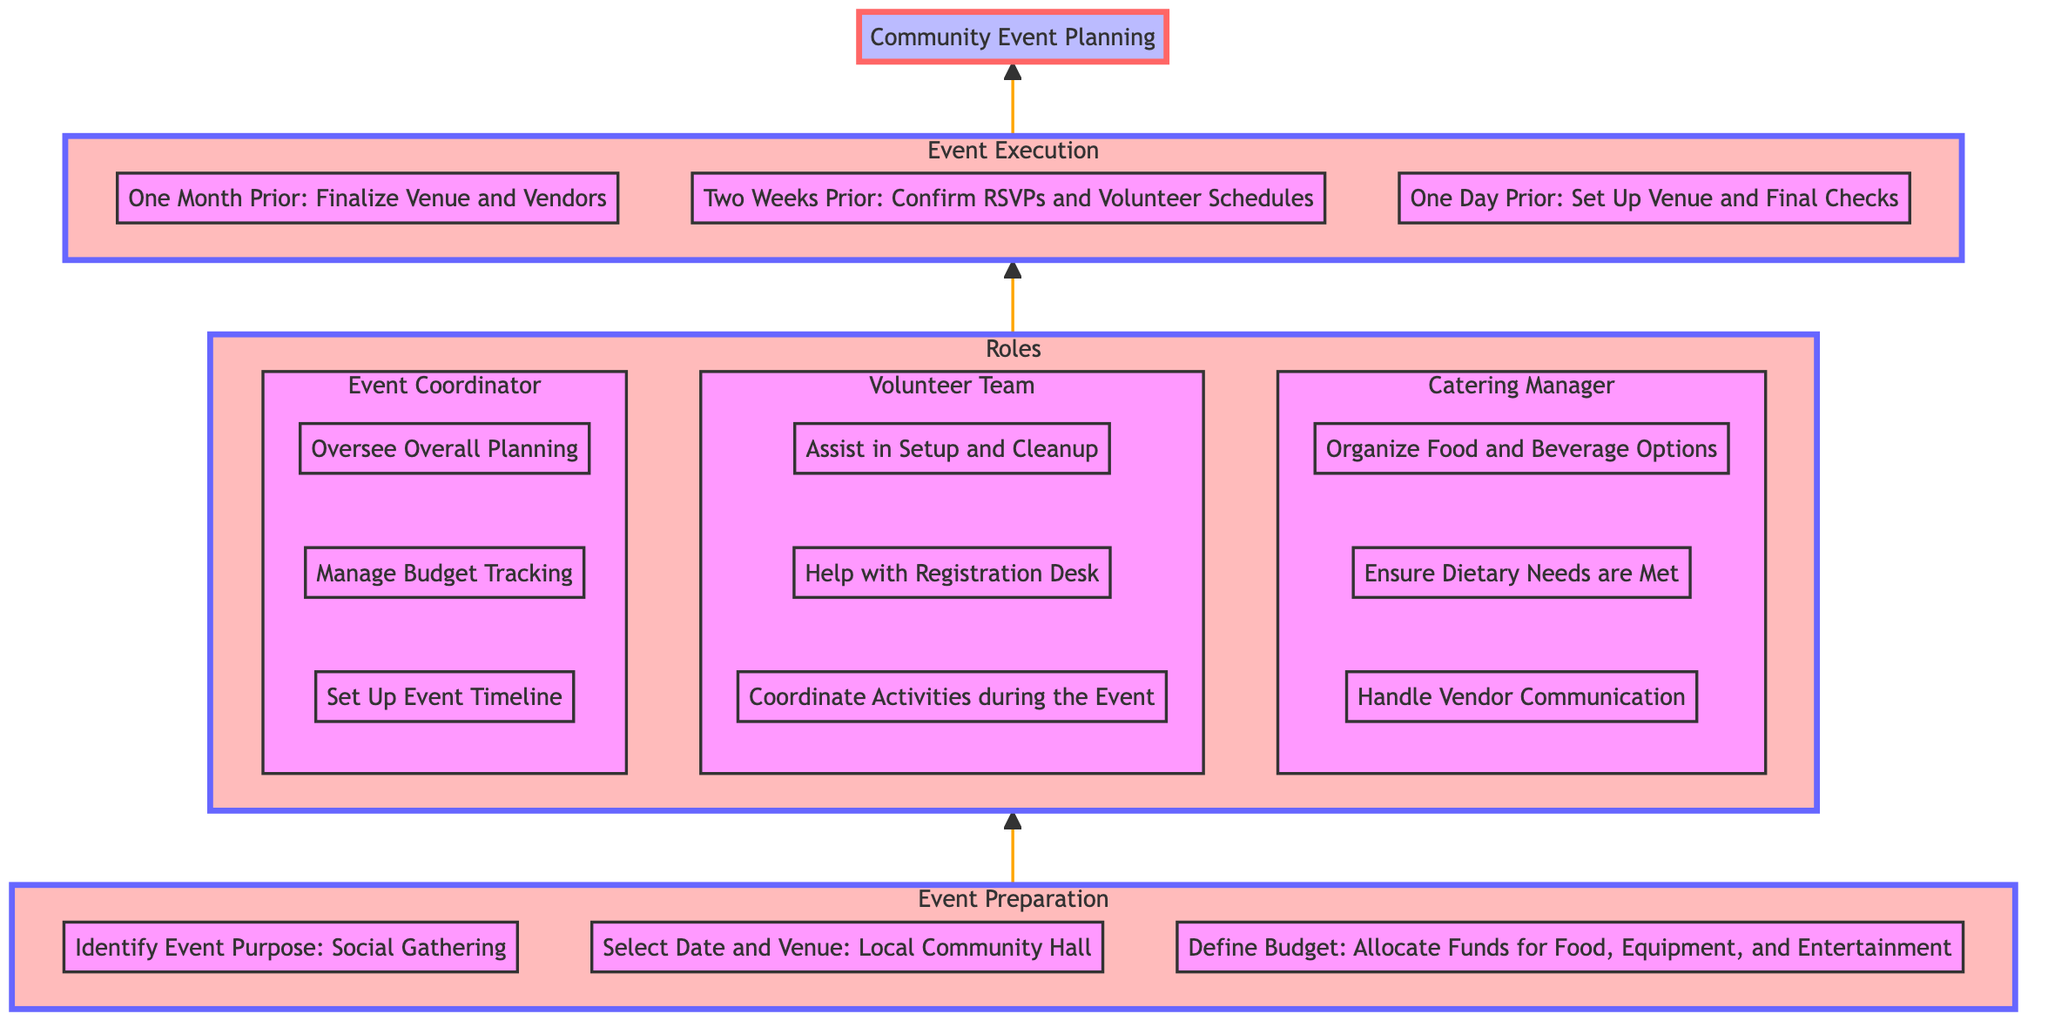What are the three tasks listed under Event Preparation? The diagram shows three specific tasks under Event Preparation: identifying the event purpose, selecting the date and venue, and defining the budget. These tasks are listed sequentially, and the focus is on the preparation stage before the actual event executes.
Answer: Identify Event Purpose: Social Gathering, Select Date and Venue: Local Community Hall, Define Budget: Allocate Funds for Food, Equipment, and Entertainment Who is responsible for managing the budget? The diagram indicates that the Event Coordinator is responsible for managing budget tracking, which is crucial for ensuring the event stays within financial limits and allocations made in the preparation stage are adhered to.
Answer: Event Coordinator What needs to be confirmed two weeks prior to the event? According to the diagram, the specific task that needs to be confirmed two weeks prior involves RSVPs and volunteer schedules. This is important for planning the flow and ensuring adequate staffing and attendance.
Answer: Confirm RSVPs and Volunteer Schedules How many roles are defined in the diagram? The diagram depicts three distinct roles: Event Coordinator, Volunteer Team, and Catering Manager. Each role has its own set of responsibilities contributing to the overall organization of the community event.
Answer: 3 Which role is responsible for handling vendor communication? The Catering Manager is identified in the diagram as responsible for handling vendor communication. This role is crucial as it ensures that all food and beverage options are organized smoothly and meets dietary needs.
Answer: Catering Manager What is the timeline stage just before the event? The diagram indicates that the stage just before the event occurs one day prior, where the focus is on setting up the venue and carrying out final checks to ensure everything is prepared for the gathering.
Answer: One Day Prior: Set Up Venue and Final Checks What is the purpose of identifying the event in the preparation phase? The purpose of identifying the event is to define the main goal of the gathering, which in this case is a social gathering. This foundational step guides all subsequent planning decisions, including tasks and responsibilities assigned.
Answer: Social Gathering What is the relationship between Event Preparation and Roles? The diagram illustrates a directional flow from Event Preparation to Roles, indicating that once the preparation tasks are identified, relevant roles and their responsibilities can then be assigned to ensure the event is successfully organized.
Answer: Event Preparation --> Roles 